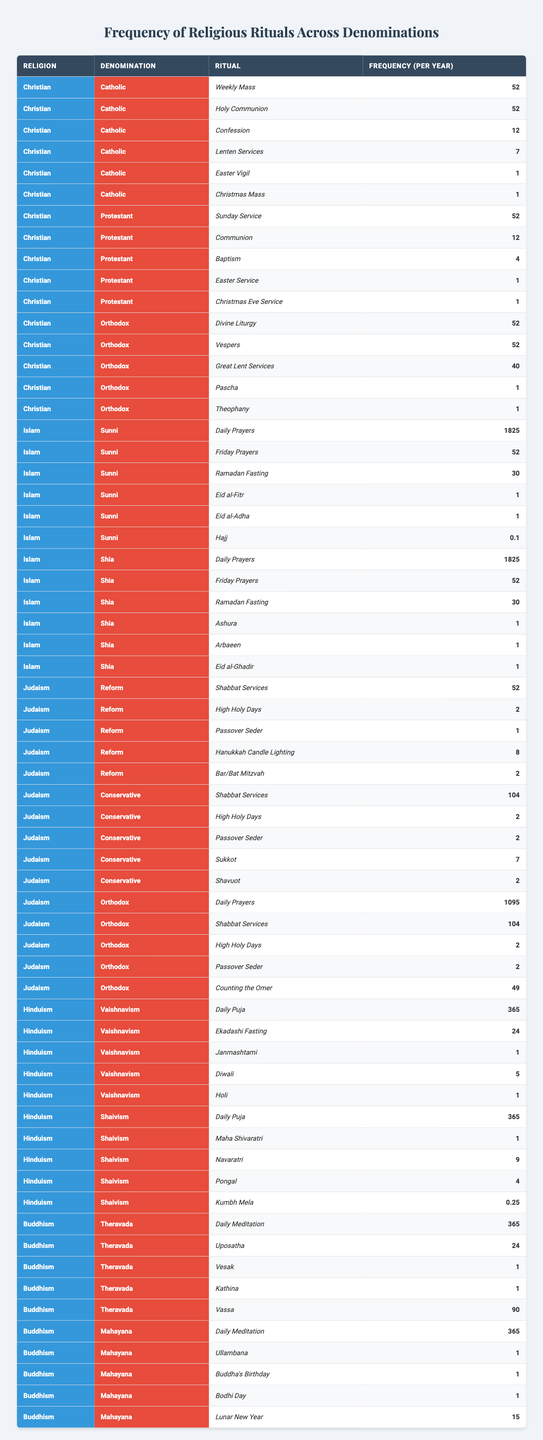What is the frequency of weekly Mass in the Catholic denomination? The table shows that the Catholic denomination performs Weekly Mass 52 times per year.
Answer: 52 Which Hindu denomination has a higher frequency of Daily Puja? Both Vaishnavism and Shaivism perform Daily Puja 365 times per year, so neither has a higher frequency; they are equal.
Answer: They are equal How many types of rituals are performed by the Orthodox Jewish denomination? The Orthodox Jewish denomination performs five types of rituals as listed in the table: Daily Prayers, Shabbat Services, High Holy Days, Passover Seder, and Counting the Omer.
Answer: 5 Does the Sunni Islam denomination perform Hajj as a ritual? The table indicates that the Sunni denomination has a frequency of 0.1 for Hajj, which suggests it is performed but not regularly, leading to a yes answer.
Answer: Yes What is the total frequency of rituals performed by the Protestant denomination? Adding the frequencies for Protestant rituals: Sunday Service (52) + Communion (12) + Baptism (4) + Easter Service (1) + Christmas Eve Service (1) = 70.
Answer: 70 Which religion has the highest number of Daily Prayers performed throughout the year, and what is that number? The table shows that both Sunni and Shia Islam denominations perform Daily Prayers 1825 times a year, which is higher than any other religion represented.
Answer: Islam, 1825 In the context of religious rituals, how does the frequency of High Holy Days differ between Reform and Conservative Judaism? The Reform denomination performs High Holy Days 2 times per year, while the Conservative denomination also performs them 2 times per year, indicating no difference.
Answer: No difference What is the average frequency of the Daily Meditation ritual across both Buddhist denominations? The frequency for Daily Meditation is 365 for both Theravada and Mahayana, so the average is (365 + 365) / 2 = 365.
Answer: 365 How many rituals does the Orthodox Christian denomination perform compared to the Catholic denomination? The Orthodox denomination performs 5 rituals, while the Catholic denomination also performs 6 rituals. The difference is 1 more ritual in the Catholic denomination.
Answer: Catholic 6, Orthodox 5 Is the frequency of Lunar New Year rituals higher than that of Vesak in Buddhism? According to the table, the Lunar New Year is performed 15 times, while Vesak is performed only once, so Lunar New Year is indeed higher.
Answer: Yes 